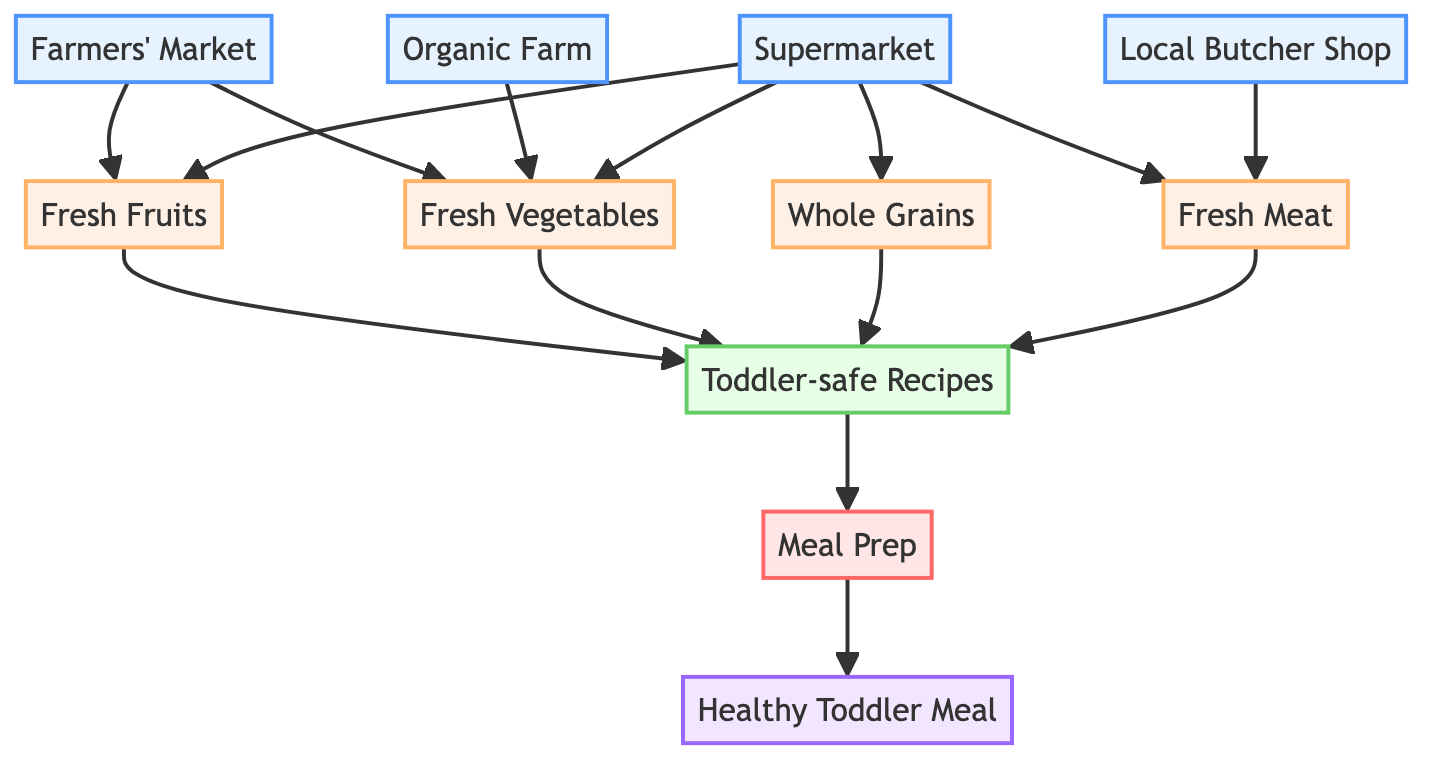What are the sources of fresh vegetables? The sources of fresh vegetables include the Farmers' Market and the Organic Farm. These sources are directly linked to the Fresh Vegetables node, showing where they originate.
Answer: Farmers' Market, Organic Farm How many item nodes are there in this diagram? The item nodes include Fresh Fruits, Fresh Vegetables, Whole Grains, and Fresh Meat. Counting these, we find there are four item nodes in total.
Answer: 4 Which food group leads to toddler-safe recipes? The food groups leading to toddler-safe recipes include Fresh Fruits, Fresh Vegetables, Whole Grains, and Fresh Meat. These four items connect directly to the Toddler-safe Recipes node.
Answer: Fresh Fruits, Fresh Vegetables, Whole Grains, Fresh Meat What type of process follows the creation of toddler-safe recipes? The process that follows the creation of toddler-safe recipes is Meal Prep. This node is directly connected to the Toddler-safe Recipes node, indicating it is the next step.
Answer: Meal Prep How many sources are there in total? The total sources listed in the diagram are the Farmers' Market, Organic Farm, Supermarket, and Local Butcher Shop. Counting all these sources gives a total of four.
Answer: 4 Which node is the end product of the process flow? The end product of the process flow is Healthy Toddler Meal. It is the final node in the chain after going through Meal Prep.
Answer: Healthy Toddler Meal What is the relationship between Supermarket and Fresh Meat? The Supermarket is a source that provides Fresh Meat. The arrow indicates a direct link from the Supermarket to the Fresh Meat node.
Answer: Source What is the role of Farmer's Market in this diagram? The role of the Farmer's Market in this diagram is to serve as a source for both Fresh Fruits and Fresh Vegetables, showing its importance in providing fresh produce.
Answer: Source for Fresh Fruits, Fresh Vegetables How do fresh fruits connect to the final meal? Fresh Fruits connect to the final meal through the following steps: they lead to Toddler-safe Recipes and then to Meal Prep, ultimately resulting in the Healthy Toddler Meal.
Answer: Through Toddler-safe Recipes, then Meal Prep 